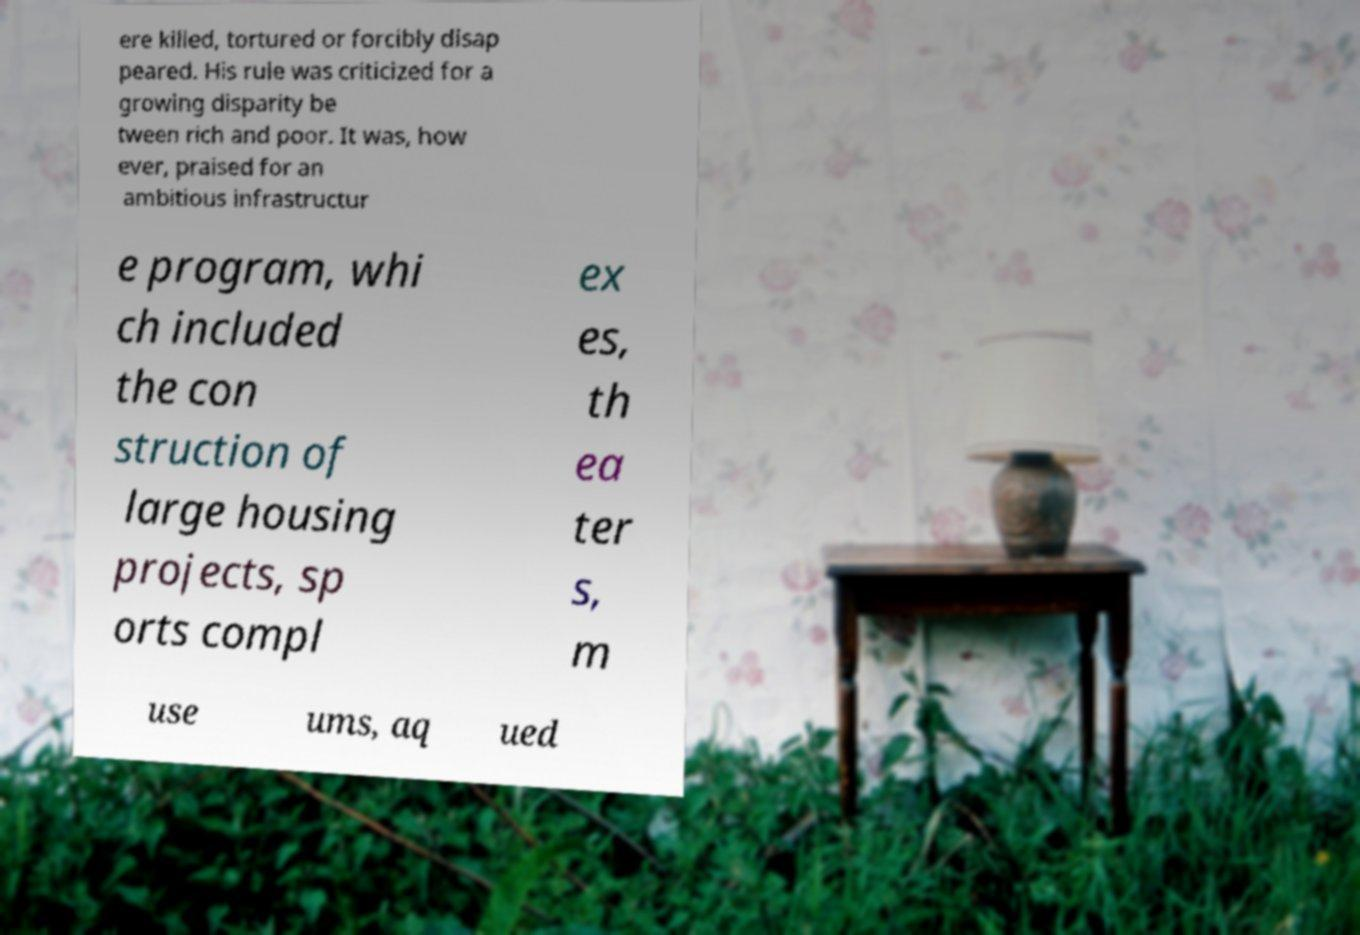Could you assist in decoding the text presented in this image and type it out clearly? ere killed, tortured or forcibly disap peared. His rule was criticized for a growing disparity be tween rich and poor. It was, how ever, praised for an ambitious infrastructur e program, whi ch included the con struction of large housing projects, sp orts compl ex es, th ea ter s, m use ums, aq ued 